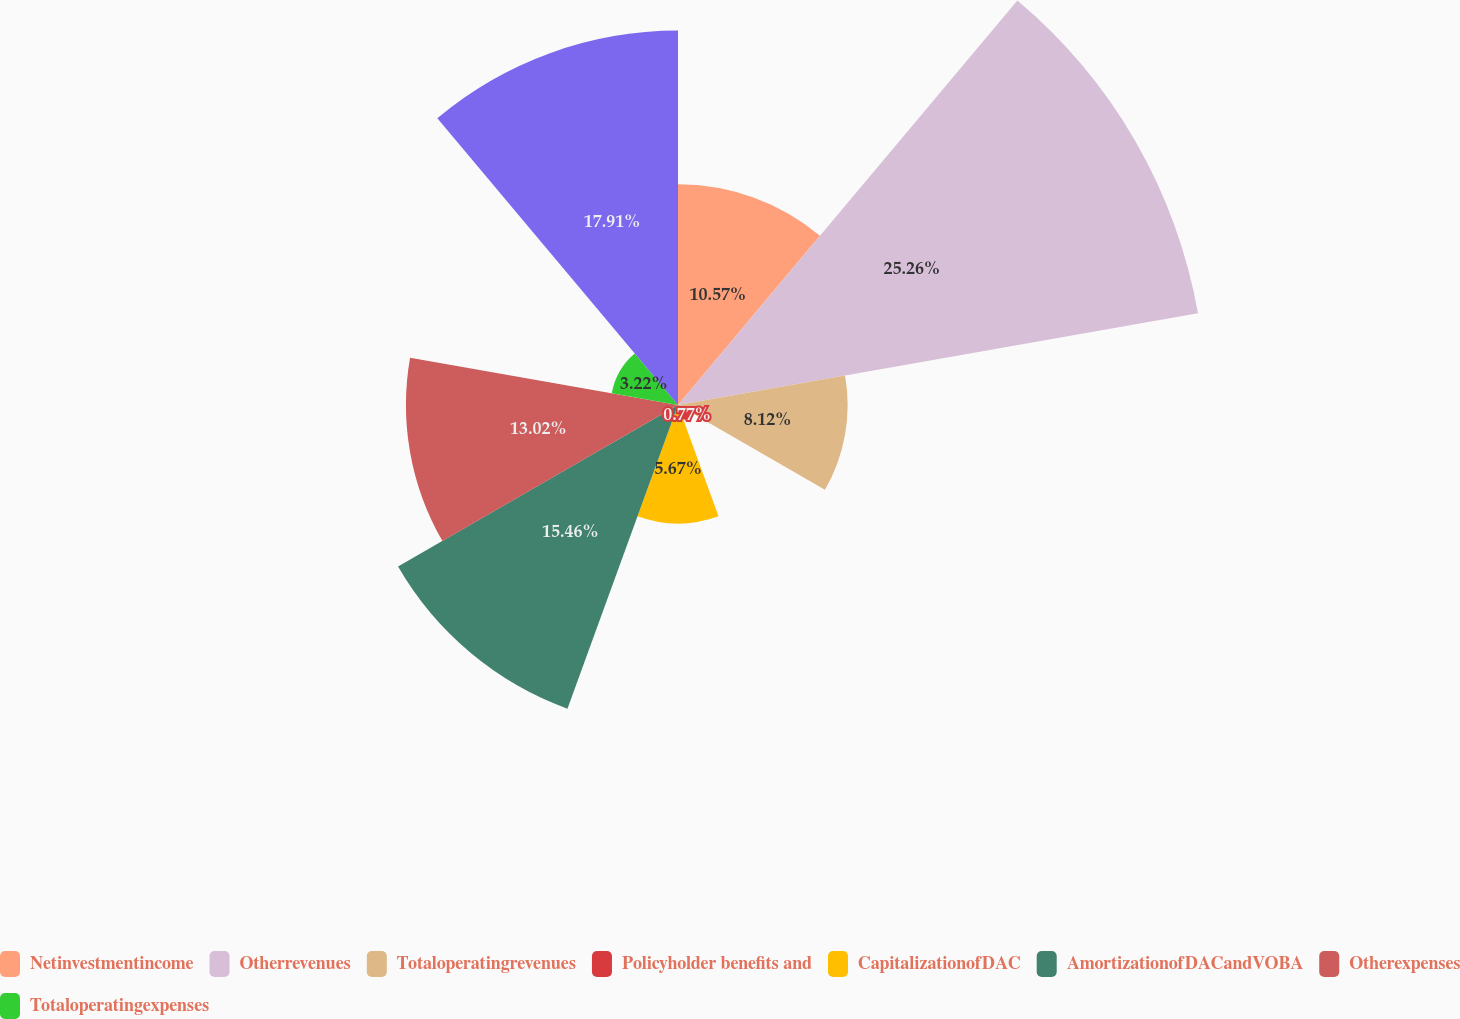<chart> <loc_0><loc_0><loc_500><loc_500><pie_chart><fcel>Netinvestmentincome<fcel>Otherrevenues<fcel>Totaloperatingrevenues<fcel>Policyholder benefits and<fcel>CapitalizationofDAC<fcel>AmortizationofDACandVOBA<fcel>Otherexpenses<fcel>Totaloperatingexpenses<fcel>Unnamed: 8<nl><fcel>10.57%<fcel>25.27%<fcel>8.12%<fcel>0.77%<fcel>5.67%<fcel>15.47%<fcel>13.02%<fcel>3.22%<fcel>17.92%<nl></chart> 